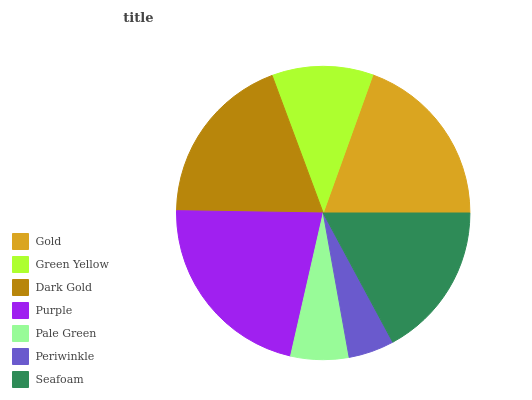Is Periwinkle the minimum?
Answer yes or no. Yes. Is Purple the maximum?
Answer yes or no. Yes. Is Green Yellow the minimum?
Answer yes or no. No. Is Green Yellow the maximum?
Answer yes or no. No. Is Gold greater than Green Yellow?
Answer yes or no. Yes. Is Green Yellow less than Gold?
Answer yes or no. Yes. Is Green Yellow greater than Gold?
Answer yes or no. No. Is Gold less than Green Yellow?
Answer yes or no. No. Is Seafoam the high median?
Answer yes or no. Yes. Is Seafoam the low median?
Answer yes or no. Yes. Is Periwinkle the high median?
Answer yes or no. No. Is Pale Green the low median?
Answer yes or no. No. 